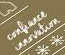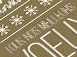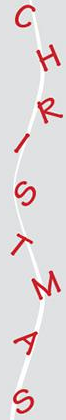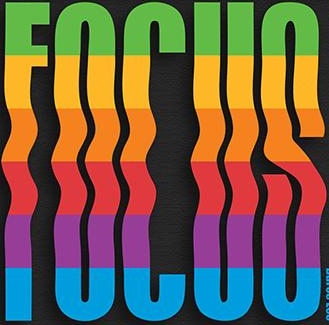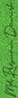Read the text from these images in sequence, separated by a semicolon. #; #; CHRISTMAS; FOCUS; # 